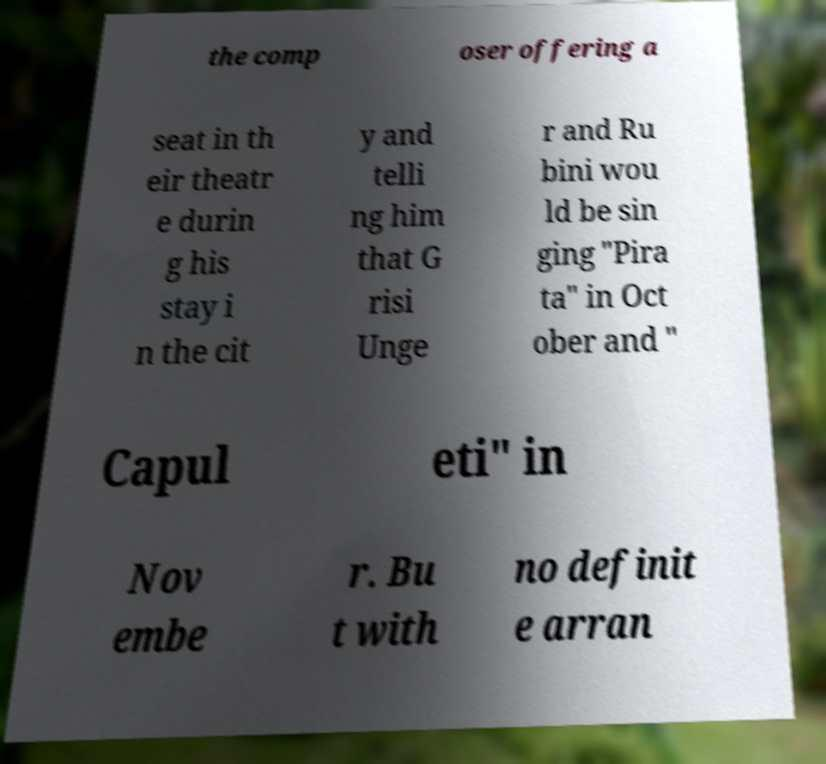There's text embedded in this image that I need extracted. Can you transcribe it verbatim? the comp oser offering a seat in th eir theatr e durin g his stay i n the cit y and telli ng him that G risi Unge r and Ru bini wou ld be sin ging "Pira ta" in Oct ober and " Capul eti" in Nov embe r. Bu t with no definit e arran 